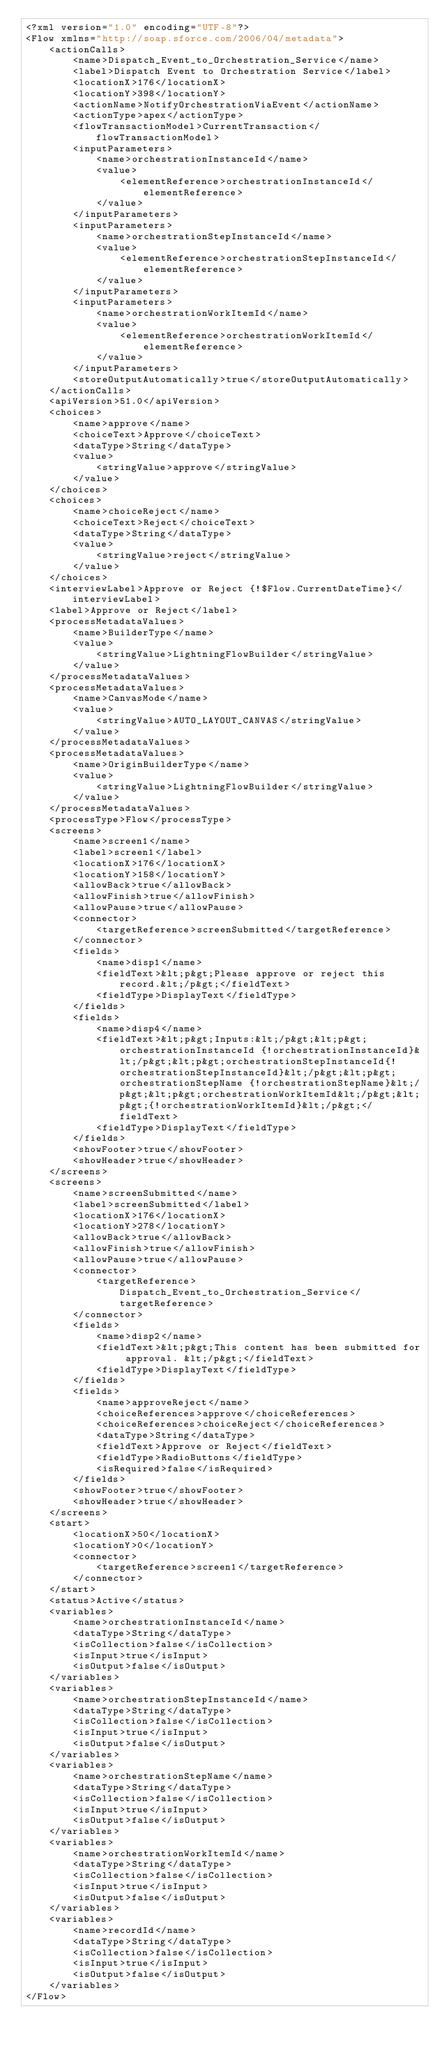<code> <loc_0><loc_0><loc_500><loc_500><_XML_><?xml version="1.0" encoding="UTF-8"?>
<Flow xmlns="http://soap.sforce.com/2006/04/metadata">
    <actionCalls>
        <name>Dispatch_Event_to_Orchestration_Service</name>
        <label>Dispatch Event to Orchestration Service</label>
        <locationX>176</locationX>
        <locationY>398</locationY>
        <actionName>NotifyOrchestrationViaEvent</actionName>
        <actionType>apex</actionType>
        <flowTransactionModel>CurrentTransaction</flowTransactionModel>
        <inputParameters>
            <name>orchestrationInstanceId</name>
            <value>
                <elementReference>orchestrationInstanceId</elementReference>
            </value>
        </inputParameters>
        <inputParameters>
            <name>orchestrationStepInstanceId</name>
            <value>
                <elementReference>orchestrationStepInstanceId</elementReference>
            </value>
        </inputParameters>
        <inputParameters>
            <name>orchestrationWorkItemId</name>
            <value>
                <elementReference>orchestrationWorkItemId</elementReference>
            </value>
        </inputParameters>
        <storeOutputAutomatically>true</storeOutputAutomatically>
    </actionCalls>
    <apiVersion>51.0</apiVersion>
    <choices>
        <name>approve</name>
        <choiceText>Approve</choiceText>
        <dataType>String</dataType>
        <value>
            <stringValue>approve</stringValue>
        </value>
    </choices>
    <choices>
        <name>choiceReject</name>
        <choiceText>Reject</choiceText>
        <dataType>String</dataType>
        <value>
            <stringValue>reject</stringValue>
        </value>
    </choices>
    <interviewLabel>Approve or Reject {!$Flow.CurrentDateTime}</interviewLabel>
    <label>Approve or Reject</label>
    <processMetadataValues>
        <name>BuilderType</name>
        <value>
            <stringValue>LightningFlowBuilder</stringValue>
        </value>
    </processMetadataValues>
    <processMetadataValues>
        <name>CanvasMode</name>
        <value>
            <stringValue>AUTO_LAYOUT_CANVAS</stringValue>
        </value>
    </processMetadataValues>
    <processMetadataValues>
        <name>OriginBuilderType</name>
        <value>
            <stringValue>LightningFlowBuilder</stringValue>
        </value>
    </processMetadataValues>
    <processType>Flow</processType>
    <screens>
        <name>screen1</name>
        <label>screen1</label>
        <locationX>176</locationX>
        <locationY>158</locationY>
        <allowBack>true</allowBack>
        <allowFinish>true</allowFinish>
        <allowPause>true</allowPause>
        <connector>
            <targetReference>screenSubmitted</targetReference>
        </connector>
        <fields>
            <name>disp1</name>
            <fieldText>&lt;p&gt;Please approve or reject this record.&lt;/p&gt;</fieldText>
            <fieldType>DisplayText</fieldType>
        </fields>
        <fields>
            <name>disp4</name>
            <fieldText>&lt;p&gt;Inputs:&lt;/p&gt;&lt;p&gt;orchestrationInstanceId {!orchestrationInstanceId}&lt;/p&gt;&lt;p&gt;orchestrationStepInstanceId{!orchestrationStepInstanceId}&lt;/p&gt;&lt;p&gt;orchestrationStepName {!orchestrationStepName}&lt;/p&gt;&lt;p&gt;orchestrationWorkItemId&lt;/p&gt;&lt;p&gt;{!orchestrationWorkItemId}&lt;/p&gt;</fieldText>
            <fieldType>DisplayText</fieldType>
        </fields>
        <showFooter>true</showFooter>
        <showHeader>true</showHeader>
    </screens>
    <screens>
        <name>screenSubmitted</name>
        <label>screenSubmitted</label>
        <locationX>176</locationX>
        <locationY>278</locationY>
        <allowBack>true</allowBack>
        <allowFinish>true</allowFinish>
        <allowPause>true</allowPause>
        <connector>
            <targetReference>Dispatch_Event_to_Orchestration_Service</targetReference>
        </connector>
        <fields>
            <name>disp2</name>
            <fieldText>&lt;p&gt;This content has been submitted for approval. &lt;/p&gt;</fieldText>
            <fieldType>DisplayText</fieldType>
        </fields>
        <fields>
            <name>approveReject</name>
            <choiceReferences>approve</choiceReferences>
            <choiceReferences>choiceReject</choiceReferences>
            <dataType>String</dataType>
            <fieldText>Approve or Reject</fieldText>
            <fieldType>RadioButtons</fieldType>
            <isRequired>false</isRequired>
        </fields>
        <showFooter>true</showFooter>
        <showHeader>true</showHeader>
    </screens>
    <start>
        <locationX>50</locationX>
        <locationY>0</locationY>
        <connector>
            <targetReference>screen1</targetReference>
        </connector>
    </start>
    <status>Active</status>
    <variables>
        <name>orchestrationInstanceId</name>
        <dataType>String</dataType>
        <isCollection>false</isCollection>
        <isInput>true</isInput>
        <isOutput>false</isOutput>
    </variables>
    <variables>
        <name>orchestrationStepInstanceId</name>
        <dataType>String</dataType>
        <isCollection>false</isCollection>
        <isInput>true</isInput>
        <isOutput>false</isOutput>
    </variables>
    <variables>
        <name>orchestrationStepName</name>
        <dataType>String</dataType>
        <isCollection>false</isCollection>
        <isInput>true</isInput>
        <isOutput>false</isOutput>
    </variables>
    <variables>
        <name>orchestrationWorkItemId</name>
        <dataType>String</dataType>
        <isCollection>false</isCollection>
        <isInput>true</isInput>
        <isOutput>false</isOutput>
    </variables>
    <variables>
        <name>recordId</name>
        <dataType>String</dataType>
        <isCollection>false</isCollection>
        <isInput>true</isInput>
        <isOutput>false</isOutput>
    </variables>
</Flow>
</code> 